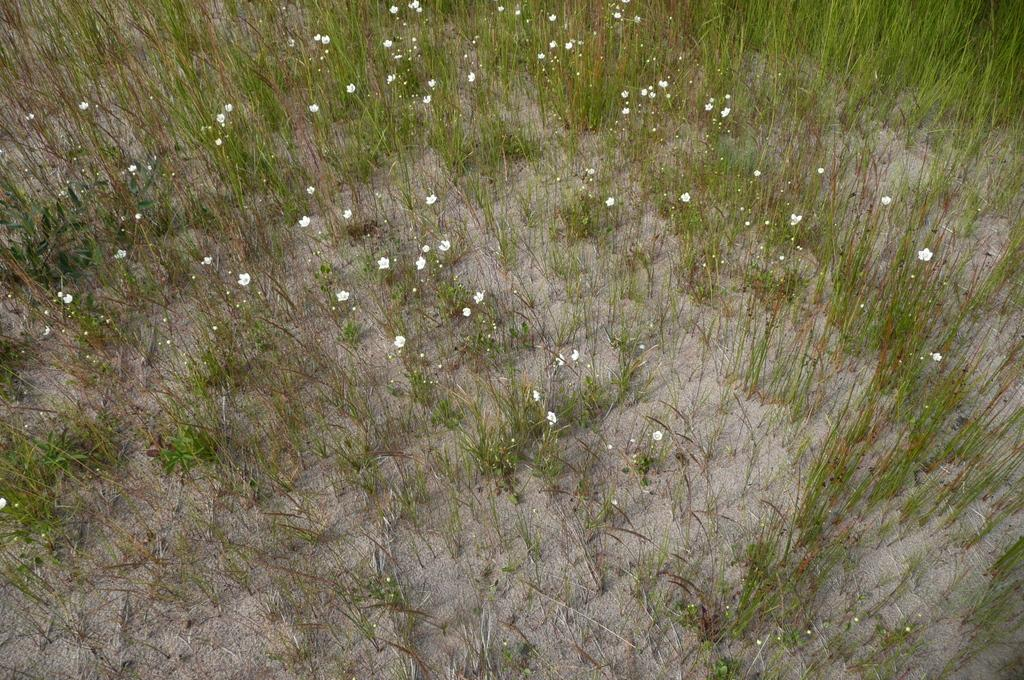What types of living organisms can be seen in the image? Plants and flowers are visible in the image. What part of the natural environment is visible in the image? The ground is visible in the image. What type of yarn can be seen in the image? There is no yarn present in the image. What creature can be seen interacting with the plants in the image? There is no creature visible in the image; it only features plants and flowers. 